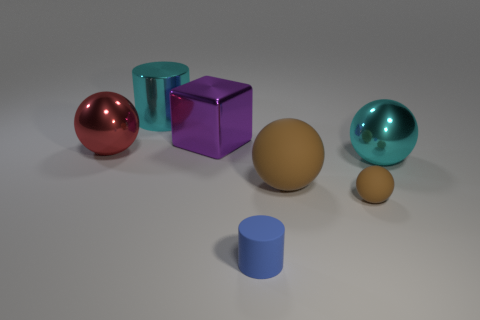Add 2 small brown rubber balls. How many objects exist? 9 Subtract all blocks. How many objects are left? 6 Subtract 0 green cylinders. How many objects are left? 7 Subtract all gray rubber balls. Subtract all small objects. How many objects are left? 5 Add 3 cylinders. How many cylinders are left? 5 Add 4 big cyan metal balls. How many big cyan metal balls exist? 5 